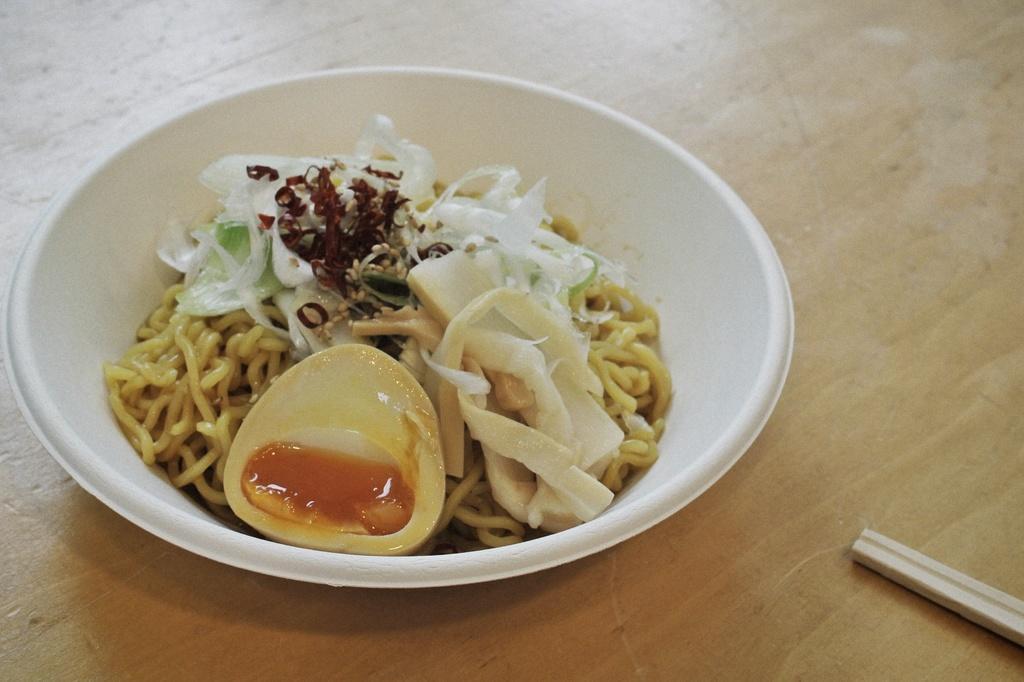Could you give a brief overview of what you see in this image? This image consists of food which is inside the bowl which is white in colour in the center. On the right side there is a wooden object. 